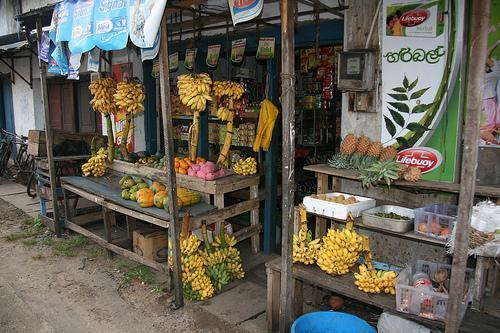How many stands are shown?
Give a very brief answer. 2. 